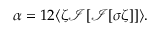<formula> <loc_0><loc_0><loc_500><loc_500>\alpha = 1 2 \langle \zeta \mathcal { I } [ \mathcal { I } [ \sigma \zeta ] ] \rangle .</formula> 